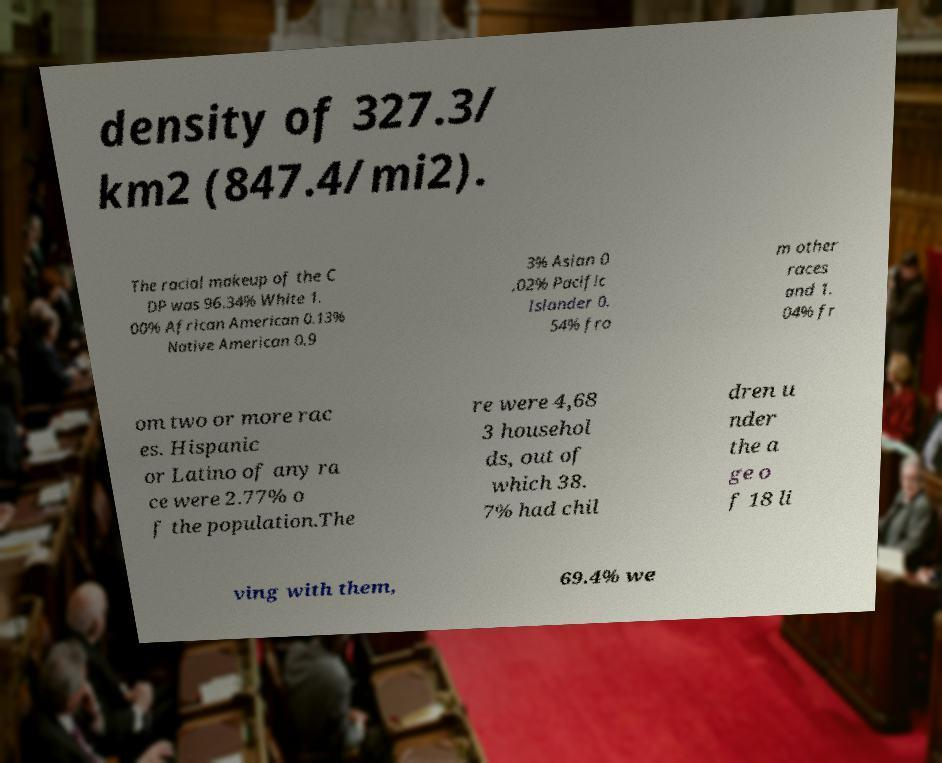There's text embedded in this image that I need extracted. Can you transcribe it verbatim? density of 327.3/ km2 (847.4/mi2). The racial makeup of the C DP was 96.34% White 1. 00% African American 0.13% Native American 0.9 3% Asian 0 .02% Pacific Islander 0. 54% fro m other races and 1. 04% fr om two or more rac es. Hispanic or Latino of any ra ce were 2.77% o f the population.The re were 4,68 3 househol ds, out of which 38. 7% had chil dren u nder the a ge o f 18 li ving with them, 69.4% we 